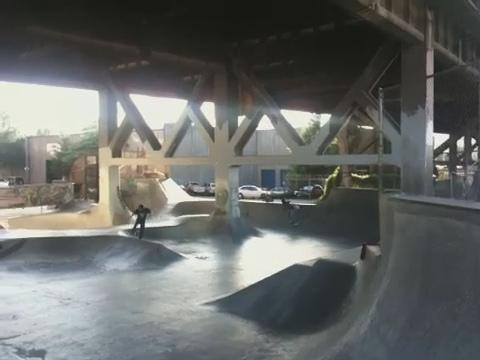Why are there mounds on the surface? for tricks 